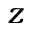Convert formula to latex. <formula><loc_0><loc_0><loc_500><loc_500>z</formula> 